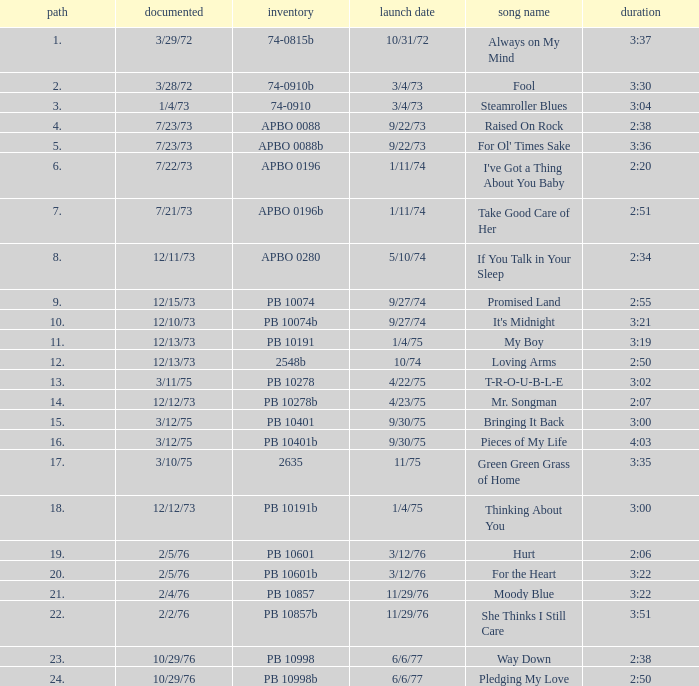Tell me the track that has the catalogue of apbo 0280 8.0. 